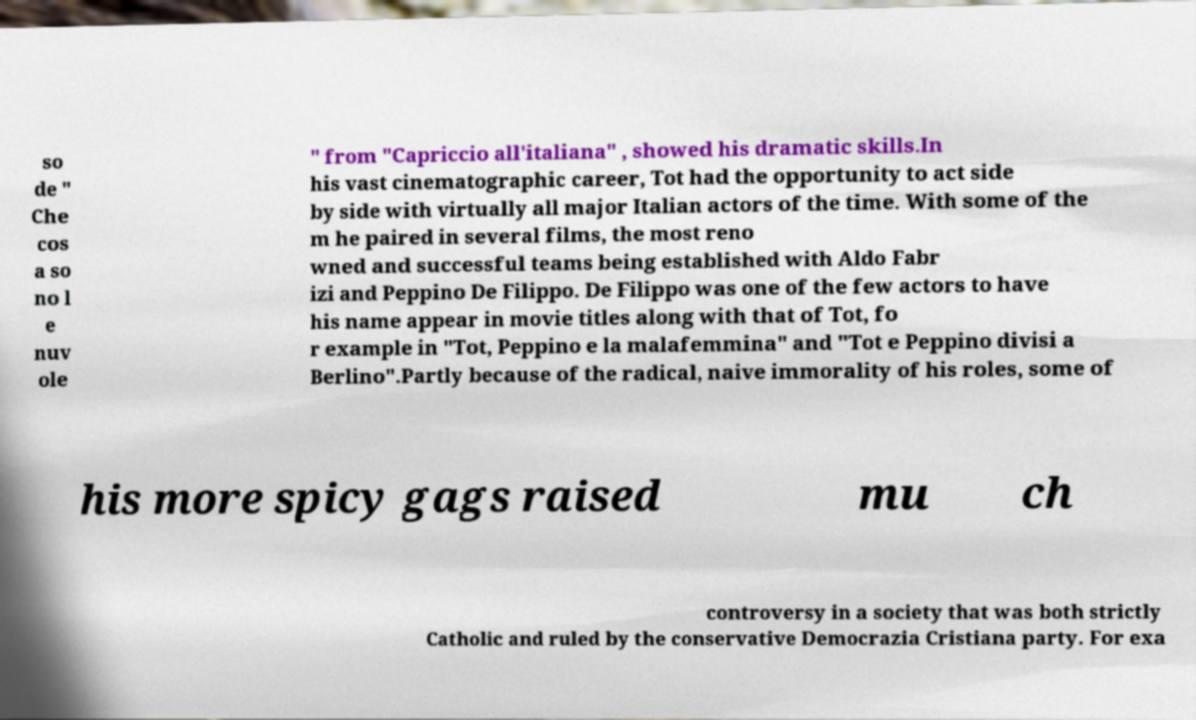I need the written content from this picture converted into text. Can you do that? so de " Che cos a so no l e nuv ole " from "Capriccio all'italiana" , showed his dramatic skills.In his vast cinematographic career, Tot had the opportunity to act side by side with virtually all major Italian actors of the time. With some of the m he paired in several films, the most reno wned and successful teams being established with Aldo Fabr izi and Peppino De Filippo. De Filippo was one of the few actors to have his name appear in movie titles along with that of Tot, fo r example in "Tot, Peppino e la malafemmina" and "Tot e Peppino divisi a Berlino".Partly because of the radical, naive immorality of his roles, some of his more spicy gags raised mu ch controversy in a society that was both strictly Catholic and ruled by the conservative Democrazia Cristiana party. For exa 